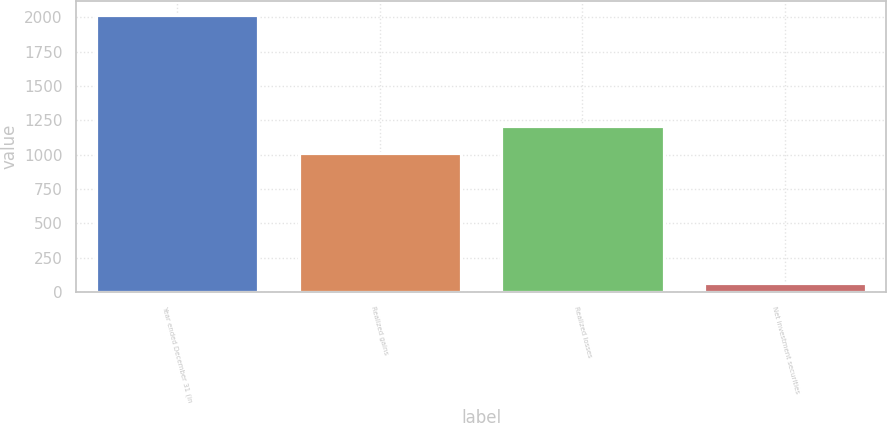Convert chart to OTSL. <chart><loc_0><loc_0><loc_500><loc_500><bar_chart><fcel>Year ended December 31 (in<fcel>Realized gains<fcel>Realized losses<fcel>Net investment securities<nl><fcel>2017<fcel>1013<fcel>1208.1<fcel>66<nl></chart> 